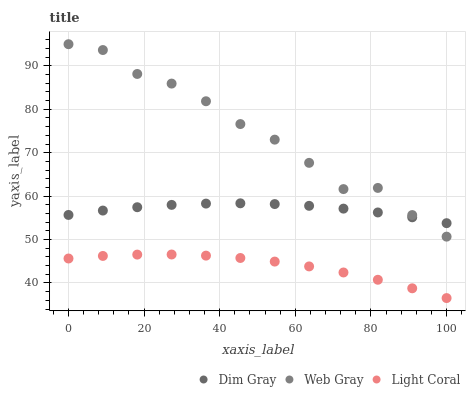Does Light Coral have the minimum area under the curve?
Answer yes or no. Yes. Does Web Gray have the maximum area under the curve?
Answer yes or no. Yes. Does Dim Gray have the minimum area under the curve?
Answer yes or no. No. Does Dim Gray have the maximum area under the curve?
Answer yes or no. No. Is Dim Gray the smoothest?
Answer yes or no. Yes. Is Web Gray the roughest?
Answer yes or no. Yes. Is Web Gray the smoothest?
Answer yes or no. No. Is Dim Gray the roughest?
Answer yes or no. No. Does Light Coral have the lowest value?
Answer yes or no. Yes. Does Web Gray have the lowest value?
Answer yes or no. No. Does Web Gray have the highest value?
Answer yes or no. Yes. Does Dim Gray have the highest value?
Answer yes or no. No. Is Light Coral less than Web Gray?
Answer yes or no. Yes. Is Web Gray greater than Light Coral?
Answer yes or no. Yes. Does Dim Gray intersect Web Gray?
Answer yes or no. Yes. Is Dim Gray less than Web Gray?
Answer yes or no. No. Is Dim Gray greater than Web Gray?
Answer yes or no. No. Does Light Coral intersect Web Gray?
Answer yes or no. No. 